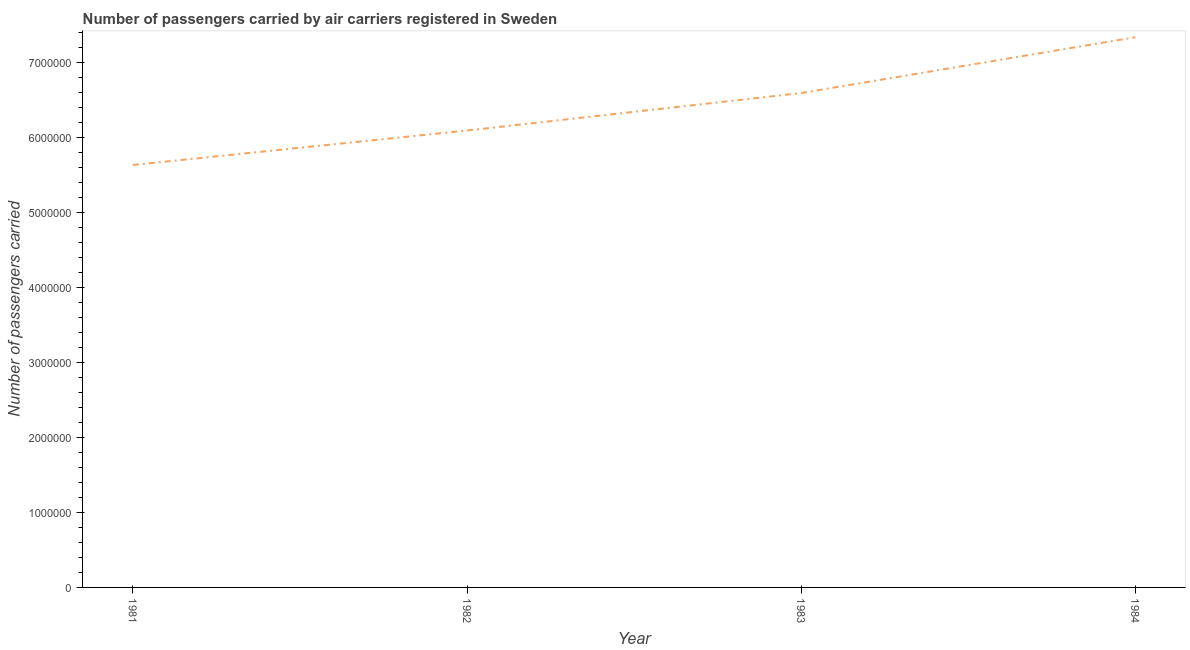What is the number of passengers carried in 1983?
Ensure brevity in your answer.  6.59e+06. Across all years, what is the maximum number of passengers carried?
Keep it short and to the point. 7.34e+06. Across all years, what is the minimum number of passengers carried?
Give a very brief answer. 5.63e+06. In which year was the number of passengers carried maximum?
Keep it short and to the point. 1984. In which year was the number of passengers carried minimum?
Make the answer very short. 1981. What is the sum of the number of passengers carried?
Give a very brief answer. 2.56e+07. What is the difference between the number of passengers carried in 1981 and 1984?
Your answer should be very brief. -1.70e+06. What is the average number of passengers carried per year?
Make the answer very short. 6.41e+06. What is the median number of passengers carried?
Offer a terse response. 6.34e+06. What is the ratio of the number of passengers carried in 1981 to that in 1983?
Make the answer very short. 0.85. What is the difference between the highest and the second highest number of passengers carried?
Provide a short and direct response. 7.44e+05. Is the sum of the number of passengers carried in 1982 and 1984 greater than the maximum number of passengers carried across all years?
Make the answer very short. Yes. What is the difference between the highest and the lowest number of passengers carried?
Provide a short and direct response. 1.70e+06. In how many years, is the number of passengers carried greater than the average number of passengers carried taken over all years?
Offer a terse response. 2. Does the number of passengers carried monotonically increase over the years?
Offer a terse response. Yes. Are the values on the major ticks of Y-axis written in scientific E-notation?
Keep it short and to the point. No. What is the title of the graph?
Provide a succinct answer. Number of passengers carried by air carriers registered in Sweden. What is the label or title of the X-axis?
Your response must be concise. Year. What is the label or title of the Y-axis?
Offer a very short reply. Number of passengers carried. What is the Number of passengers carried of 1981?
Provide a succinct answer. 5.63e+06. What is the Number of passengers carried in 1982?
Your answer should be compact. 6.09e+06. What is the Number of passengers carried of 1983?
Provide a short and direct response. 6.59e+06. What is the Number of passengers carried in 1984?
Your answer should be compact. 7.34e+06. What is the difference between the Number of passengers carried in 1981 and 1982?
Make the answer very short. -4.59e+05. What is the difference between the Number of passengers carried in 1981 and 1983?
Offer a very short reply. -9.59e+05. What is the difference between the Number of passengers carried in 1981 and 1984?
Ensure brevity in your answer.  -1.70e+06. What is the difference between the Number of passengers carried in 1982 and 1983?
Ensure brevity in your answer.  -5.00e+05. What is the difference between the Number of passengers carried in 1982 and 1984?
Ensure brevity in your answer.  -1.24e+06. What is the difference between the Number of passengers carried in 1983 and 1984?
Make the answer very short. -7.44e+05. What is the ratio of the Number of passengers carried in 1981 to that in 1982?
Make the answer very short. 0.93. What is the ratio of the Number of passengers carried in 1981 to that in 1983?
Make the answer very short. 0.85. What is the ratio of the Number of passengers carried in 1981 to that in 1984?
Offer a very short reply. 0.77. What is the ratio of the Number of passengers carried in 1982 to that in 1983?
Your answer should be very brief. 0.92. What is the ratio of the Number of passengers carried in 1982 to that in 1984?
Your answer should be very brief. 0.83. What is the ratio of the Number of passengers carried in 1983 to that in 1984?
Offer a very short reply. 0.9. 